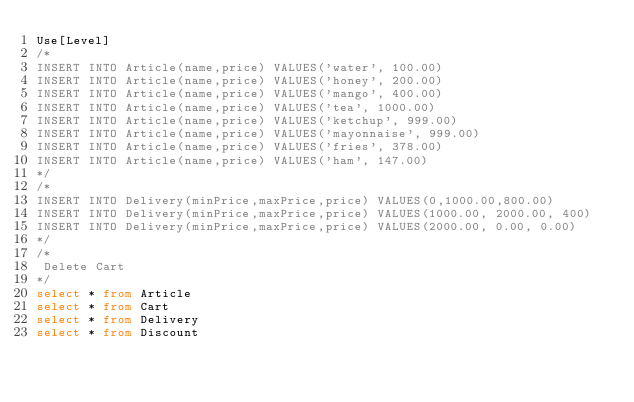Convert code to text. <code><loc_0><loc_0><loc_500><loc_500><_SQL_>Use[Level]
/*
INSERT INTO Article(name,price) VALUES('water', 100.00)
INSERT INTO Article(name,price) VALUES('honey', 200.00)
INSERT INTO Article(name,price) VALUES('mango', 400.00)
INSERT INTO Article(name,price) VALUES('tea', 1000.00)
INSERT INTO Article(name,price) VALUES('ketchup', 999.00)
INSERT INTO Article(name,price) VALUES('mayonnaise', 999.00)
INSERT INTO Article(name,price) VALUES('fries', 378.00)
INSERT INTO Article(name,price) VALUES('ham', 147.00)
*/
/*
INSERT INTO Delivery(minPrice,maxPrice,price) VALUES(0,1000.00,800.00)
INSERT INTO Delivery(minPrice,maxPrice,price) VALUES(1000.00, 2000.00, 400)
INSERT INTO Delivery(minPrice,maxPrice,price) VALUES(2000.00, 0.00, 0.00)
*/
/*
 Delete Cart
*/
select * from Article
select * from Cart
select * from Delivery
select * from Discount</code> 